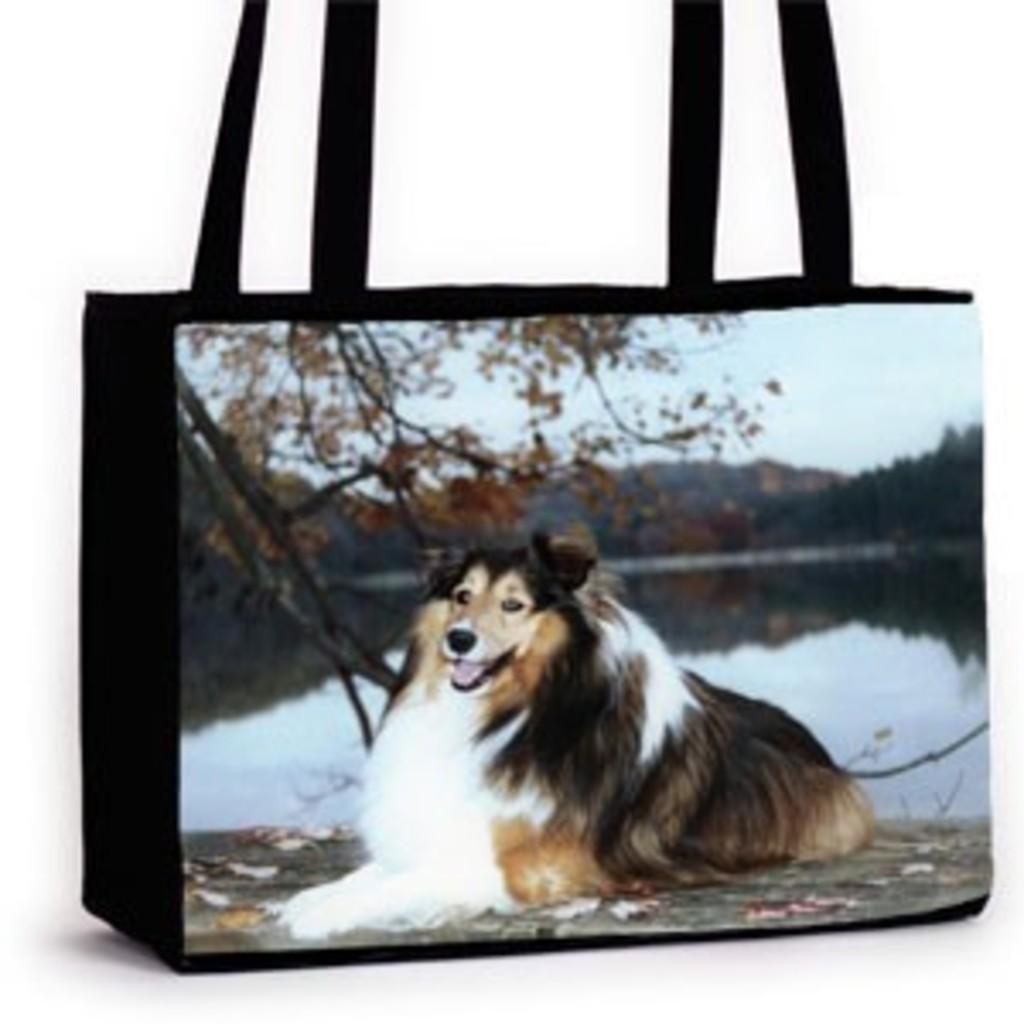Can you describe this image briefly? In this picture we can see a bag with straps to it and on bag we can see a dog sitting floor and aside to this dog we have water, trees, mountains, sky. 